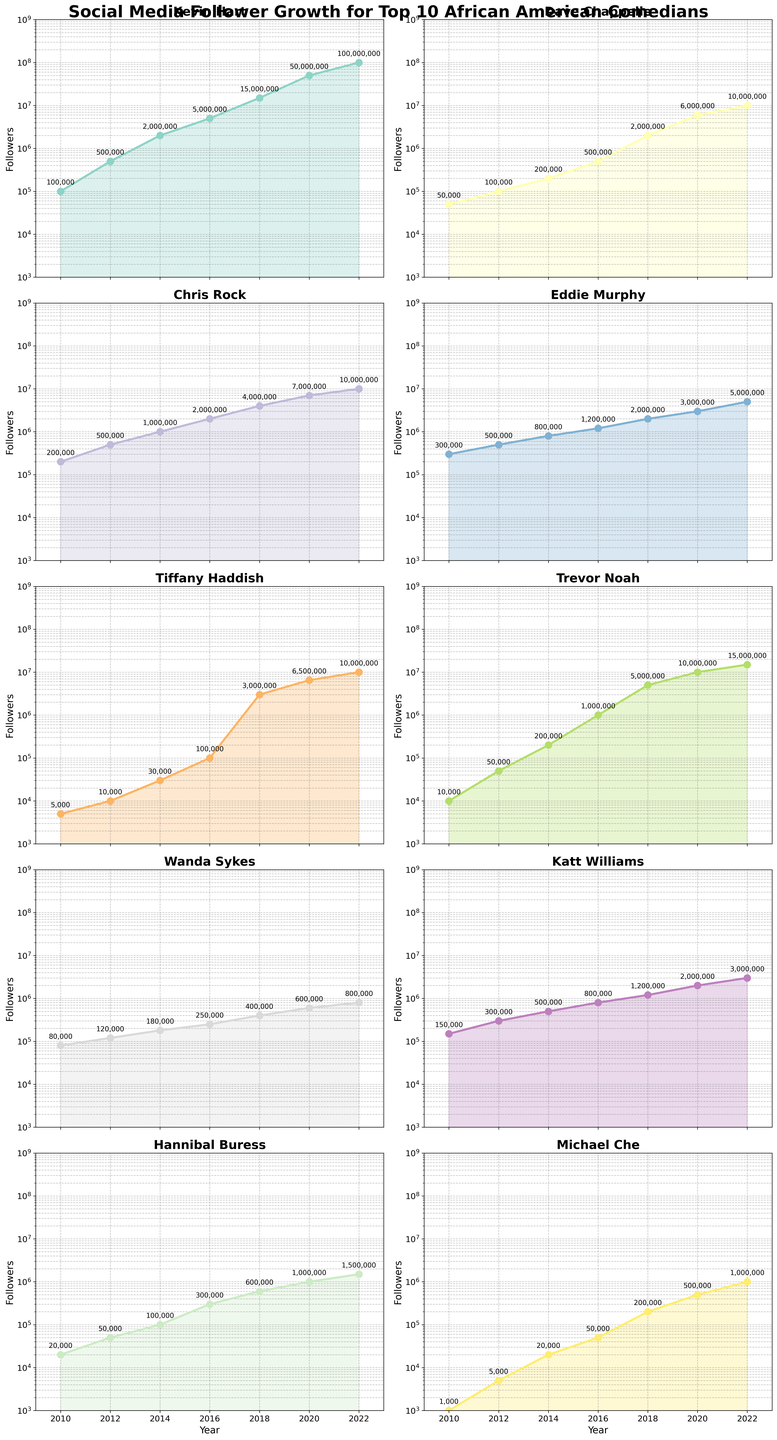How many comedians are represented in the figure? The figure is a set of vertical subplots, each representing a different comedian's social media follower growth over time. There are 10 subplots in total, one for each comedian.
Answer: 10 What is the title of the figure? The title of the figure is displayed at the top and reads: 'Social Media Follower Growth for Top 10 African American Comedians'.
Answer: 'Social Media Follower Growth for Top 10 African American Comedians' Which comedian had the highest number of followers in 2022? By looking at the last data points in the subplots for 2022, Kevin Hart's subplot shows he had the highest number of followers in 2022.
Answer: Kevin Hart How did Tiffany Haddish's followers grow between 2010 and 2012? By examining Tiffany Haddish's subplot, her followers grew from 5000 in 2010 to 10,000 in 2012. The increase is 10,000 - 5,000 = 5,000 followers.
Answer: 5,000 followers When did Trevor Noah experience the largest growth in followers? Trevor Noah's subplot shows a significant jump between 2016 and 2018, where his followers grew from about 1,000,000 to 5,000,000.
Answer: Between 2016 and 2018 Compared to 2010, how many more followers did Chris Rock have in 2020? Chris Rock's followers in 2010 were 200,000. In 2020, they were 7,000,000. The increase is 7,000,000 - 200,000 = 6,800,000 followers.
Answer: 6,800,000 followers Which comedian had the smallest follower growth from 2020 to 2022? By comparing the growth in followers for each subplot between 2020 and 2022, Wanda Sykes had the smallest increase, from 600,000 to 800,000, growing by 200,000.
Answer: Wanda Sykes What trend is observed in Michael Che's follower count over the years? Michael Che's subplot shows a steady increase in followers over the years, ending with significant growth, especially from 2018 to 2022.
Answer: Steady increase If you sum the total number of followers for Eddie Murphy in 2018 and 2022, what is the value? Eddie Murphy had 2,000,000 followers in 2018 and 5,000,000 in 2022. Summing these gives 2,000,000 + 5,000,000 = 7,000,000.
Answer: 7,000,000 Who had a faster growth rate in followers from 2014 to 2020: Katt Williams or Hannibal Buress? Katt Williams grew from 500,000 to 2,000,000, an increase of 1,500,000. Hannibal Buress grew from 100,000 to 1,000,000, an increase of 900,000. Thus, Katt Williams had a faster growth rate.
Answer: Katt Williams 